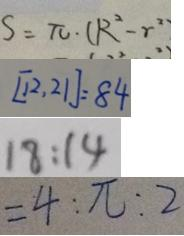Convert formula to latex. <formula><loc_0><loc_0><loc_500><loc_500>S = \pi \cdot ( R ^ { 2 } - r ^ { 2 } ) 
 [ 1 2 , 2 1 ] = 8 4 
 1 8 : 1 4 
 = 4 : \pi : 2</formula> 